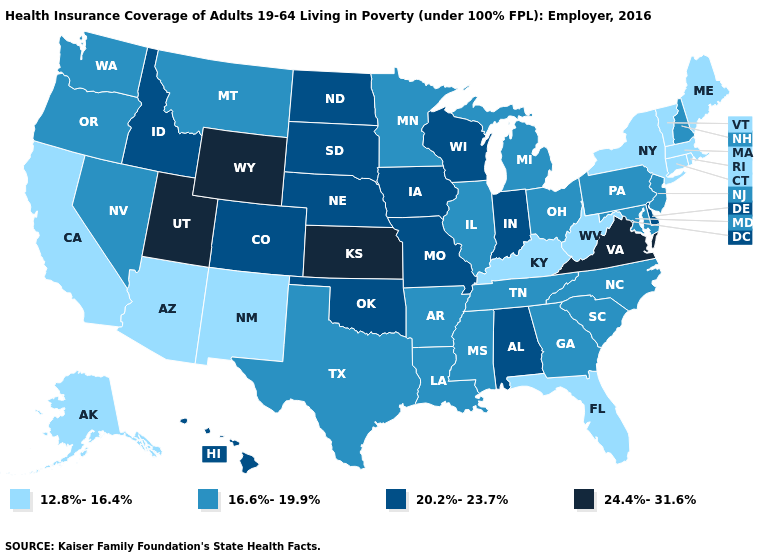Name the states that have a value in the range 16.6%-19.9%?
Keep it brief. Arkansas, Georgia, Illinois, Louisiana, Maryland, Michigan, Minnesota, Mississippi, Montana, Nevada, New Hampshire, New Jersey, North Carolina, Ohio, Oregon, Pennsylvania, South Carolina, Tennessee, Texas, Washington. Name the states that have a value in the range 20.2%-23.7%?
Be succinct. Alabama, Colorado, Delaware, Hawaii, Idaho, Indiana, Iowa, Missouri, Nebraska, North Dakota, Oklahoma, South Dakota, Wisconsin. What is the value of West Virginia?
Give a very brief answer. 12.8%-16.4%. Is the legend a continuous bar?
Concise answer only. No. Among the states that border Michigan , does Wisconsin have the lowest value?
Write a very short answer. No. What is the value of Washington?
Keep it brief. 16.6%-19.9%. Name the states that have a value in the range 24.4%-31.6%?
Quick response, please. Kansas, Utah, Virginia, Wyoming. Name the states that have a value in the range 24.4%-31.6%?
Give a very brief answer. Kansas, Utah, Virginia, Wyoming. Does Delaware have the lowest value in the South?
Concise answer only. No. What is the lowest value in the MidWest?
Quick response, please. 16.6%-19.9%. What is the value of Louisiana?
Keep it brief. 16.6%-19.9%. What is the highest value in the USA?
Give a very brief answer. 24.4%-31.6%. Name the states that have a value in the range 16.6%-19.9%?
Be succinct. Arkansas, Georgia, Illinois, Louisiana, Maryland, Michigan, Minnesota, Mississippi, Montana, Nevada, New Hampshire, New Jersey, North Carolina, Ohio, Oregon, Pennsylvania, South Carolina, Tennessee, Texas, Washington. Does Delaware have a lower value than Utah?
Give a very brief answer. Yes. Name the states that have a value in the range 20.2%-23.7%?
Write a very short answer. Alabama, Colorado, Delaware, Hawaii, Idaho, Indiana, Iowa, Missouri, Nebraska, North Dakota, Oklahoma, South Dakota, Wisconsin. 